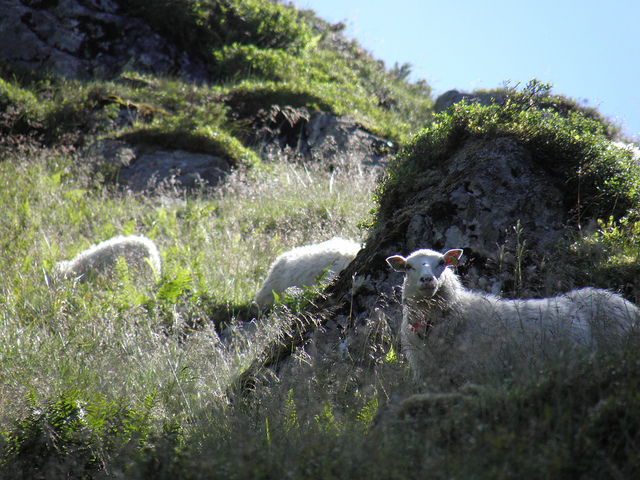How many sheep are in the photo? 3 